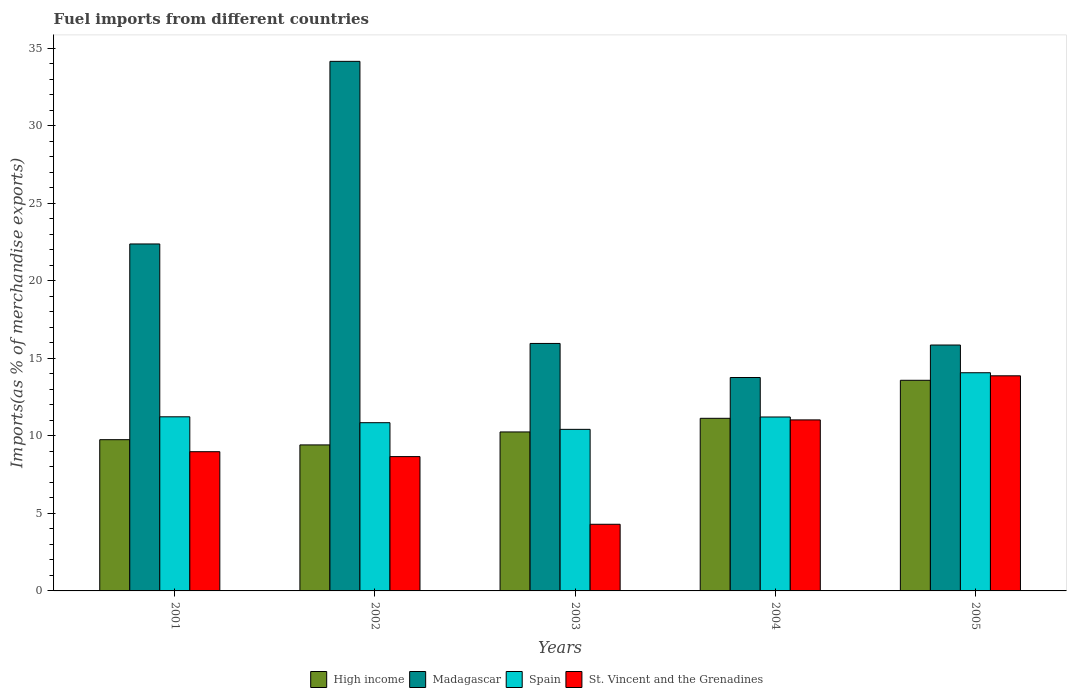How many different coloured bars are there?
Keep it short and to the point. 4. How many groups of bars are there?
Provide a short and direct response. 5. Are the number of bars per tick equal to the number of legend labels?
Your response must be concise. Yes. How many bars are there on the 2nd tick from the left?
Provide a short and direct response. 4. What is the percentage of imports to different countries in Spain in 2005?
Give a very brief answer. 14.07. Across all years, what is the maximum percentage of imports to different countries in High income?
Keep it short and to the point. 13.59. Across all years, what is the minimum percentage of imports to different countries in High income?
Ensure brevity in your answer.  9.42. In which year was the percentage of imports to different countries in St. Vincent and the Grenadines maximum?
Give a very brief answer. 2005. In which year was the percentage of imports to different countries in High income minimum?
Provide a succinct answer. 2002. What is the total percentage of imports to different countries in St. Vincent and the Grenadines in the graph?
Provide a succinct answer. 46.86. What is the difference between the percentage of imports to different countries in St. Vincent and the Grenadines in 2001 and that in 2004?
Make the answer very short. -2.05. What is the difference between the percentage of imports to different countries in Spain in 2001 and the percentage of imports to different countries in High income in 2002?
Provide a short and direct response. 1.81. What is the average percentage of imports to different countries in High income per year?
Your answer should be compact. 10.83. In the year 2003, what is the difference between the percentage of imports to different countries in Madagascar and percentage of imports to different countries in St. Vincent and the Grenadines?
Offer a terse response. 11.66. What is the ratio of the percentage of imports to different countries in High income in 2001 to that in 2002?
Make the answer very short. 1.04. Is the difference between the percentage of imports to different countries in Madagascar in 2004 and 2005 greater than the difference between the percentage of imports to different countries in St. Vincent and the Grenadines in 2004 and 2005?
Provide a short and direct response. Yes. What is the difference between the highest and the second highest percentage of imports to different countries in St. Vincent and the Grenadines?
Ensure brevity in your answer.  2.84. What is the difference between the highest and the lowest percentage of imports to different countries in Spain?
Make the answer very short. 3.65. In how many years, is the percentage of imports to different countries in Madagascar greater than the average percentage of imports to different countries in Madagascar taken over all years?
Provide a succinct answer. 2. Is the sum of the percentage of imports to different countries in High income in 2001 and 2003 greater than the maximum percentage of imports to different countries in Madagascar across all years?
Keep it short and to the point. No. Is it the case that in every year, the sum of the percentage of imports to different countries in Spain and percentage of imports to different countries in St. Vincent and the Grenadines is greater than the sum of percentage of imports to different countries in Madagascar and percentage of imports to different countries in High income?
Provide a succinct answer. No. What does the 2nd bar from the left in 2002 represents?
Make the answer very short. Madagascar. What does the 3rd bar from the right in 2002 represents?
Your answer should be very brief. Madagascar. Is it the case that in every year, the sum of the percentage of imports to different countries in High income and percentage of imports to different countries in Madagascar is greater than the percentage of imports to different countries in St. Vincent and the Grenadines?
Offer a terse response. Yes. How many bars are there?
Offer a terse response. 20. What is the difference between two consecutive major ticks on the Y-axis?
Your answer should be compact. 5. Does the graph contain grids?
Your answer should be very brief. No. Where does the legend appear in the graph?
Make the answer very short. Bottom center. How many legend labels are there?
Provide a succinct answer. 4. How are the legend labels stacked?
Keep it short and to the point. Horizontal. What is the title of the graph?
Your answer should be very brief. Fuel imports from different countries. Does "Botswana" appear as one of the legend labels in the graph?
Provide a succinct answer. No. What is the label or title of the Y-axis?
Ensure brevity in your answer.  Imports(as % of merchandise exports). What is the Imports(as % of merchandise exports) in High income in 2001?
Make the answer very short. 9.76. What is the Imports(as % of merchandise exports) of Madagascar in 2001?
Offer a terse response. 22.38. What is the Imports(as % of merchandise exports) of Spain in 2001?
Provide a succinct answer. 11.23. What is the Imports(as % of merchandise exports) in St. Vincent and the Grenadines in 2001?
Your answer should be compact. 8.98. What is the Imports(as % of merchandise exports) of High income in 2002?
Keep it short and to the point. 9.42. What is the Imports(as % of merchandise exports) in Madagascar in 2002?
Give a very brief answer. 34.16. What is the Imports(as % of merchandise exports) in Spain in 2002?
Give a very brief answer. 10.85. What is the Imports(as % of merchandise exports) in St. Vincent and the Grenadines in 2002?
Your answer should be compact. 8.67. What is the Imports(as % of merchandise exports) in High income in 2003?
Offer a terse response. 10.26. What is the Imports(as % of merchandise exports) in Madagascar in 2003?
Make the answer very short. 15.96. What is the Imports(as % of merchandise exports) in Spain in 2003?
Provide a short and direct response. 10.42. What is the Imports(as % of merchandise exports) in St. Vincent and the Grenadines in 2003?
Offer a terse response. 4.3. What is the Imports(as % of merchandise exports) in High income in 2004?
Keep it short and to the point. 11.14. What is the Imports(as % of merchandise exports) in Madagascar in 2004?
Offer a very short reply. 13.77. What is the Imports(as % of merchandise exports) in Spain in 2004?
Provide a succinct answer. 11.22. What is the Imports(as % of merchandise exports) of St. Vincent and the Grenadines in 2004?
Give a very brief answer. 11.03. What is the Imports(as % of merchandise exports) of High income in 2005?
Your answer should be compact. 13.59. What is the Imports(as % of merchandise exports) of Madagascar in 2005?
Keep it short and to the point. 15.86. What is the Imports(as % of merchandise exports) of Spain in 2005?
Give a very brief answer. 14.07. What is the Imports(as % of merchandise exports) of St. Vincent and the Grenadines in 2005?
Make the answer very short. 13.88. Across all years, what is the maximum Imports(as % of merchandise exports) of High income?
Keep it short and to the point. 13.59. Across all years, what is the maximum Imports(as % of merchandise exports) in Madagascar?
Offer a terse response. 34.16. Across all years, what is the maximum Imports(as % of merchandise exports) in Spain?
Your answer should be very brief. 14.07. Across all years, what is the maximum Imports(as % of merchandise exports) in St. Vincent and the Grenadines?
Offer a very short reply. 13.88. Across all years, what is the minimum Imports(as % of merchandise exports) in High income?
Make the answer very short. 9.42. Across all years, what is the minimum Imports(as % of merchandise exports) in Madagascar?
Your response must be concise. 13.77. Across all years, what is the minimum Imports(as % of merchandise exports) of Spain?
Ensure brevity in your answer.  10.42. Across all years, what is the minimum Imports(as % of merchandise exports) in St. Vincent and the Grenadines?
Ensure brevity in your answer.  4.3. What is the total Imports(as % of merchandise exports) of High income in the graph?
Provide a succinct answer. 54.15. What is the total Imports(as % of merchandise exports) in Madagascar in the graph?
Offer a very short reply. 102.14. What is the total Imports(as % of merchandise exports) of Spain in the graph?
Your answer should be very brief. 57.8. What is the total Imports(as % of merchandise exports) of St. Vincent and the Grenadines in the graph?
Make the answer very short. 46.86. What is the difference between the Imports(as % of merchandise exports) in High income in 2001 and that in 2002?
Offer a terse response. 0.34. What is the difference between the Imports(as % of merchandise exports) in Madagascar in 2001 and that in 2002?
Your response must be concise. -11.78. What is the difference between the Imports(as % of merchandise exports) in Spain in 2001 and that in 2002?
Offer a terse response. 0.38. What is the difference between the Imports(as % of merchandise exports) of St. Vincent and the Grenadines in 2001 and that in 2002?
Provide a succinct answer. 0.32. What is the difference between the Imports(as % of merchandise exports) in High income in 2001 and that in 2003?
Ensure brevity in your answer.  -0.5. What is the difference between the Imports(as % of merchandise exports) in Madagascar in 2001 and that in 2003?
Provide a short and direct response. 6.42. What is the difference between the Imports(as % of merchandise exports) in Spain in 2001 and that in 2003?
Your answer should be compact. 0.81. What is the difference between the Imports(as % of merchandise exports) of St. Vincent and the Grenadines in 2001 and that in 2003?
Provide a succinct answer. 4.68. What is the difference between the Imports(as % of merchandise exports) in High income in 2001 and that in 2004?
Provide a succinct answer. -1.38. What is the difference between the Imports(as % of merchandise exports) of Madagascar in 2001 and that in 2004?
Your answer should be very brief. 8.61. What is the difference between the Imports(as % of merchandise exports) in Spain in 2001 and that in 2004?
Your answer should be compact. 0.01. What is the difference between the Imports(as % of merchandise exports) of St. Vincent and the Grenadines in 2001 and that in 2004?
Make the answer very short. -2.05. What is the difference between the Imports(as % of merchandise exports) of High income in 2001 and that in 2005?
Make the answer very short. -3.83. What is the difference between the Imports(as % of merchandise exports) of Madagascar in 2001 and that in 2005?
Give a very brief answer. 6.52. What is the difference between the Imports(as % of merchandise exports) in Spain in 2001 and that in 2005?
Keep it short and to the point. -2.84. What is the difference between the Imports(as % of merchandise exports) of St. Vincent and the Grenadines in 2001 and that in 2005?
Your answer should be compact. -4.9. What is the difference between the Imports(as % of merchandise exports) in High income in 2002 and that in 2003?
Provide a succinct answer. -0.84. What is the difference between the Imports(as % of merchandise exports) of Madagascar in 2002 and that in 2003?
Make the answer very short. 18.2. What is the difference between the Imports(as % of merchandise exports) of Spain in 2002 and that in 2003?
Make the answer very short. 0.43. What is the difference between the Imports(as % of merchandise exports) of St. Vincent and the Grenadines in 2002 and that in 2003?
Provide a short and direct response. 4.37. What is the difference between the Imports(as % of merchandise exports) in High income in 2002 and that in 2004?
Your answer should be very brief. -1.72. What is the difference between the Imports(as % of merchandise exports) of Madagascar in 2002 and that in 2004?
Keep it short and to the point. 20.39. What is the difference between the Imports(as % of merchandise exports) in Spain in 2002 and that in 2004?
Your response must be concise. -0.37. What is the difference between the Imports(as % of merchandise exports) of St. Vincent and the Grenadines in 2002 and that in 2004?
Your answer should be very brief. -2.37. What is the difference between the Imports(as % of merchandise exports) in High income in 2002 and that in 2005?
Your answer should be compact. -4.17. What is the difference between the Imports(as % of merchandise exports) of Madagascar in 2002 and that in 2005?
Your answer should be very brief. 18.3. What is the difference between the Imports(as % of merchandise exports) in Spain in 2002 and that in 2005?
Make the answer very short. -3.22. What is the difference between the Imports(as % of merchandise exports) of St. Vincent and the Grenadines in 2002 and that in 2005?
Your response must be concise. -5.21. What is the difference between the Imports(as % of merchandise exports) of High income in 2003 and that in 2004?
Your answer should be very brief. -0.88. What is the difference between the Imports(as % of merchandise exports) of Madagascar in 2003 and that in 2004?
Make the answer very short. 2.2. What is the difference between the Imports(as % of merchandise exports) in Spain in 2003 and that in 2004?
Provide a succinct answer. -0.8. What is the difference between the Imports(as % of merchandise exports) of St. Vincent and the Grenadines in 2003 and that in 2004?
Ensure brevity in your answer.  -6.73. What is the difference between the Imports(as % of merchandise exports) in High income in 2003 and that in 2005?
Ensure brevity in your answer.  -3.33. What is the difference between the Imports(as % of merchandise exports) in Madagascar in 2003 and that in 2005?
Give a very brief answer. 0.1. What is the difference between the Imports(as % of merchandise exports) in Spain in 2003 and that in 2005?
Provide a short and direct response. -3.65. What is the difference between the Imports(as % of merchandise exports) in St. Vincent and the Grenadines in 2003 and that in 2005?
Keep it short and to the point. -9.58. What is the difference between the Imports(as % of merchandise exports) in High income in 2004 and that in 2005?
Make the answer very short. -2.45. What is the difference between the Imports(as % of merchandise exports) in Madagascar in 2004 and that in 2005?
Your answer should be very brief. -2.09. What is the difference between the Imports(as % of merchandise exports) in Spain in 2004 and that in 2005?
Keep it short and to the point. -2.85. What is the difference between the Imports(as % of merchandise exports) of St. Vincent and the Grenadines in 2004 and that in 2005?
Ensure brevity in your answer.  -2.84. What is the difference between the Imports(as % of merchandise exports) of High income in 2001 and the Imports(as % of merchandise exports) of Madagascar in 2002?
Give a very brief answer. -24.41. What is the difference between the Imports(as % of merchandise exports) in High income in 2001 and the Imports(as % of merchandise exports) in Spain in 2002?
Provide a short and direct response. -1.1. What is the difference between the Imports(as % of merchandise exports) in High income in 2001 and the Imports(as % of merchandise exports) in St. Vincent and the Grenadines in 2002?
Make the answer very short. 1.09. What is the difference between the Imports(as % of merchandise exports) in Madagascar in 2001 and the Imports(as % of merchandise exports) in Spain in 2002?
Offer a very short reply. 11.53. What is the difference between the Imports(as % of merchandise exports) in Madagascar in 2001 and the Imports(as % of merchandise exports) in St. Vincent and the Grenadines in 2002?
Offer a very short reply. 13.72. What is the difference between the Imports(as % of merchandise exports) in Spain in 2001 and the Imports(as % of merchandise exports) in St. Vincent and the Grenadines in 2002?
Keep it short and to the point. 2.57. What is the difference between the Imports(as % of merchandise exports) in High income in 2001 and the Imports(as % of merchandise exports) in Madagascar in 2003?
Give a very brief answer. -6.21. What is the difference between the Imports(as % of merchandise exports) in High income in 2001 and the Imports(as % of merchandise exports) in Spain in 2003?
Provide a succinct answer. -0.67. What is the difference between the Imports(as % of merchandise exports) in High income in 2001 and the Imports(as % of merchandise exports) in St. Vincent and the Grenadines in 2003?
Offer a terse response. 5.46. What is the difference between the Imports(as % of merchandise exports) of Madagascar in 2001 and the Imports(as % of merchandise exports) of Spain in 2003?
Provide a succinct answer. 11.96. What is the difference between the Imports(as % of merchandise exports) in Madagascar in 2001 and the Imports(as % of merchandise exports) in St. Vincent and the Grenadines in 2003?
Keep it short and to the point. 18.08. What is the difference between the Imports(as % of merchandise exports) in Spain in 2001 and the Imports(as % of merchandise exports) in St. Vincent and the Grenadines in 2003?
Give a very brief answer. 6.93. What is the difference between the Imports(as % of merchandise exports) of High income in 2001 and the Imports(as % of merchandise exports) of Madagascar in 2004?
Make the answer very short. -4.01. What is the difference between the Imports(as % of merchandise exports) of High income in 2001 and the Imports(as % of merchandise exports) of Spain in 2004?
Your answer should be compact. -1.46. What is the difference between the Imports(as % of merchandise exports) of High income in 2001 and the Imports(as % of merchandise exports) of St. Vincent and the Grenadines in 2004?
Your answer should be very brief. -1.28. What is the difference between the Imports(as % of merchandise exports) in Madagascar in 2001 and the Imports(as % of merchandise exports) in Spain in 2004?
Your answer should be compact. 11.16. What is the difference between the Imports(as % of merchandise exports) of Madagascar in 2001 and the Imports(as % of merchandise exports) of St. Vincent and the Grenadines in 2004?
Keep it short and to the point. 11.35. What is the difference between the Imports(as % of merchandise exports) of Spain in 2001 and the Imports(as % of merchandise exports) of St. Vincent and the Grenadines in 2004?
Your response must be concise. 0.2. What is the difference between the Imports(as % of merchandise exports) of High income in 2001 and the Imports(as % of merchandise exports) of Madagascar in 2005?
Ensure brevity in your answer.  -6.11. What is the difference between the Imports(as % of merchandise exports) in High income in 2001 and the Imports(as % of merchandise exports) in Spain in 2005?
Keep it short and to the point. -4.32. What is the difference between the Imports(as % of merchandise exports) of High income in 2001 and the Imports(as % of merchandise exports) of St. Vincent and the Grenadines in 2005?
Provide a short and direct response. -4.12. What is the difference between the Imports(as % of merchandise exports) of Madagascar in 2001 and the Imports(as % of merchandise exports) of Spain in 2005?
Your answer should be compact. 8.31. What is the difference between the Imports(as % of merchandise exports) of Madagascar in 2001 and the Imports(as % of merchandise exports) of St. Vincent and the Grenadines in 2005?
Keep it short and to the point. 8.51. What is the difference between the Imports(as % of merchandise exports) in Spain in 2001 and the Imports(as % of merchandise exports) in St. Vincent and the Grenadines in 2005?
Your answer should be very brief. -2.64. What is the difference between the Imports(as % of merchandise exports) in High income in 2002 and the Imports(as % of merchandise exports) in Madagascar in 2003?
Give a very brief answer. -6.55. What is the difference between the Imports(as % of merchandise exports) of High income in 2002 and the Imports(as % of merchandise exports) of Spain in 2003?
Give a very brief answer. -1. What is the difference between the Imports(as % of merchandise exports) of High income in 2002 and the Imports(as % of merchandise exports) of St. Vincent and the Grenadines in 2003?
Your answer should be very brief. 5.12. What is the difference between the Imports(as % of merchandise exports) in Madagascar in 2002 and the Imports(as % of merchandise exports) in Spain in 2003?
Provide a short and direct response. 23.74. What is the difference between the Imports(as % of merchandise exports) in Madagascar in 2002 and the Imports(as % of merchandise exports) in St. Vincent and the Grenadines in 2003?
Your answer should be compact. 29.86. What is the difference between the Imports(as % of merchandise exports) of Spain in 2002 and the Imports(as % of merchandise exports) of St. Vincent and the Grenadines in 2003?
Provide a succinct answer. 6.55. What is the difference between the Imports(as % of merchandise exports) of High income in 2002 and the Imports(as % of merchandise exports) of Madagascar in 2004?
Offer a terse response. -4.35. What is the difference between the Imports(as % of merchandise exports) in High income in 2002 and the Imports(as % of merchandise exports) in Spain in 2004?
Give a very brief answer. -1.8. What is the difference between the Imports(as % of merchandise exports) of High income in 2002 and the Imports(as % of merchandise exports) of St. Vincent and the Grenadines in 2004?
Make the answer very short. -1.61. What is the difference between the Imports(as % of merchandise exports) of Madagascar in 2002 and the Imports(as % of merchandise exports) of Spain in 2004?
Offer a terse response. 22.94. What is the difference between the Imports(as % of merchandise exports) of Madagascar in 2002 and the Imports(as % of merchandise exports) of St. Vincent and the Grenadines in 2004?
Ensure brevity in your answer.  23.13. What is the difference between the Imports(as % of merchandise exports) in Spain in 2002 and the Imports(as % of merchandise exports) in St. Vincent and the Grenadines in 2004?
Provide a succinct answer. -0.18. What is the difference between the Imports(as % of merchandise exports) in High income in 2002 and the Imports(as % of merchandise exports) in Madagascar in 2005?
Your answer should be very brief. -6.44. What is the difference between the Imports(as % of merchandise exports) in High income in 2002 and the Imports(as % of merchandise exports) in Spain in 2005?
Ensure brevity in your answer.  -4.66. What is the difference between the Imports(as % of merchandise exports) of High income in 2002 and the Imports(as % of merchandise exports) of St. Vincent and the Grenadines in 2005?
Your answer should be very brief. -4.46. What is the difference between the Imports(as % of merchandise exports) in Madagascar in 2002 and the Imports(as % of merchandise exports) in Spain in 2005?
Provide a short and direct response. 20.09. What is the difference between the Imports(as % of merchandise exports) in Madagascar in 2002 and the Imports(as % of merchandise exports) in St. Vincent and the Grenadines in 2005?
Your response must be concise. 20.29. What is the difference between the Imports(as % of merchandise exports) of Spain in 2002 and the Imports(as % of merchandise exports) of St. Vincent and the Grenadines in 2005?
Offer a very short reply. -3.02. What is the difference between the Imports(as % of merchandise exports) of High income in 2003 and the Imports(as % of merchandise exports) of Madagascar in 2004?
Offer a very short reply. -3.51. What is the difference between the Imports(as % of merchandise exports) in High income in 2003 and the Imports(as % of merchandise exports) in Spain in 2004?
Your answer should be very brief. -0.96. What is the difference between the Imports(as % of merchandise exports) of High income in 2003 and the Imports(as % of merchandise exports) of St. Vincent and the Grenadines in 2004?
Your answer should be very brief. -0.78. What is the difference between the Imports(as % of merchandise exports) of Madagascar in 2003 and the Imports(as % of merchandise exports) of Spain in 2004?
Provide a succinct answer. 4.74. What is the difference between the Imports(as % of merchandise exports) in Madagascar in 2003 and the Imports(as % of merchandise exports) in St. Vincent and the Grenadines in 2004?
Provide a short and direct response. 4.93. What is the difference between the Imports(as % of merchandise exports) of Spain in 2003 and the Imports(as % of merchandise exports) of St. Vincent and the Grenadines in 2004?
Ensure brevity in your answer.  -0.61. What is the difference between the Imports(as % of merchandise exports) of High income in 2003 and the Imports(as % of merchandise exports) of Madagascar in 2005?
Your answer should be compact. -5.61. What is the difference between the Imports(as % of merchandise exports) in High income in 2003 and the Imports(as % of merchandise exports) in Spain in 2005?
Offer a terse response. -3.82. What is the difference between the Imports(as % of merchandise exports) of High income in 2003 and the Imports(as % of merchandise exports) of St. Vincent and the Grenadines in 2005?
Provide a succinct answer. -3.62. What is the difference between the Imports(as % of merchandise exports) in Madagascar in 2003 and the Imports(as % of merchandise exports) in Spain in 2005?
Make the answer very short. 1.89. What is the difference between the Imports(as % of merchandise exports) in Madagascar in 2003 and the Imports(as % of merchandise exports) in St. Vincent and the Grenadines in 2005?
Give a very brief answer. 2.09. What is the difference between the Imports(as % of merchandise exports) of Spain in 2003 and the Imports(as % of merchandise exports) of St. Vincent and the Grenadines in 2005?
Offer a terse response. -3.45. What is the difference between the Imports(as % of merchandise exports) in High income in 2004 and the Imports(as % of merchandise exports) in Madagascar in 2005?
Keep it short and to the point. -4.73. What is the difference between the Imports(as % of merchandise exports) in High income in 2004 and the Imports(as % of merchandise exports) in Spain in 2005?
Your answer should be compact. -2.94. What is the difference between the Imports(as % of merchandise exports) in High income in 2004 and the Imports(as % of merchandise exports) in St. Vincent and the Grenadines in 2005?
Offer a very short reply. -2.74. What is the difference between the Imports(as % of merchandise exports) in Madagascar in 2004 and the Imports(as % of merchandise exports) in Spain in 2005?
Give a very brief answer. -0.31. What is the difference between the Imports(as % of merchandise exports) in Madagascar in 2004 and the Imports(as % of merchandise exports) in St. Vincent and the Grenadines in 2005?
Offer a terse response. -0.11. What is the difference between the Imports(as % of merchandise exports) in Spain in 2004 and the Imports(as % of merchandise exports) in St. Vincent and the Grenadines in 2005?
Your response must be concise. -2.66. What is the average Imports(as % of merchandise exports) of High income per year?
Offer a terse response. 10.83. What is the average Imports(as % of merchandise exports) in Madagascar per year?
Keep it short and to the point. 20.43. What is the average Imports(as % of merchandise exports) in Spain per year?
Offer a very short reply. 11.56. What is the average Imports(as % of merchandise exports) in St. Vincent and the Grenadines per year?
Provide a succinct answer. 9.37. In the year 2001, what is the difference between the Imports(as % of merchandise exports) in High income and Imports(as % of merchandise exports) in Madagascar?
Ensure brevity in your answer.  -12.63. In the year 2001, what is the difference between the Imports(as % of merchandise exports) in High income and Imports(as % of merchandise exports) in Spain?
Provide a succinct answer. -1.48. In the year 2001, what is the difference between the Imports(as % of merchandise exports) in High income and Imports(as % of merchandise exports) in St. Vincent and the Grenadines?
Provide a short and direct response. 0.77. In the year 2001, what is the difference between the Imports(as % of merchandise exports) in Madagascar and Imports(as % of merchandise exports) in Spain?
Provide a short and direct response. 11.15. In the year 2001, what is the difference between the Imports(as % of merchandise exports) of Madagascar and Imports(as % of merchandise exports) of St. Vincent and the Grenadines?
Your response must be concise. 13.4. In the year 2001, what is the difference between the Imports(as % of merchandise exports) in Spain and Imports(as % of merchandise exports) in St. Vincent and the Grenadines?
Keep it short and to the point. 2.25. In the year 2002, what is the difference between the Imports(as % of merchandise exports) of High income and Imports(as % of merchandise exports) of Madagascar?
Provide a succinct answer. -24.74. In the year 2002, what is the difference between the Imports(as % of merchandise exports) of High income and Imports(as % of merchandise exports) of Spain?
Keep it short and to the point. -1.43. In the year 2002, what is the difference between the Imports(as % of merchandise exports) of High income and Imports(as % of merchandise exports) of St. Vincent and the Grenadines?
Provide a succinct answer. 0.75. In the year 2002, what is the difference between the Imports(as % of merchandise exports) of Madagascar and Imports(as % of merchandise exports) of Spain?
Your response must be concise. 23.31. In the year 2002, what is the difference between the Imports(as % of merchandise exports) of Madagascar and Imports(as % of merchandise exports) of St. Vincent and the Grenadines?
Your answer should be very brief. 25.5. In the year 2002, what is the difference between the Imports(as % of merchandise exports) of Spain and Imports(as % of merchandise exports) of St. Vincent and the Grenadines?
Keep it short and to the point. 2.19. In the year 2003, what is the difference between the Imports(as % of merchandise exports) in High income and Imports(as % of merchandise exports) in Madagascar?
Make the answer very short. -5.71. In the year 2003, what is the difference between the Imports(as % of merchandise exports) of High income and Imports(as % of merchandise exports) of Spain?
Your answer should be very brief. -0.17. In the year 2003, what is the difference between the Imports(as % of merchandise exports) in High income and Imports(as % of merchandise exports) in St. Vincent and the Grenadines?
Offer a terse response. 5.96. In the year 2003, what is the difference between the Imports(as % of merchandise exports) in Madagascar and Imports(as % of merchandise exports) in Spain?
Provide a short and direct response. 5.54. In the year 2003, what is the difference between the Imports(as % of merchandise exports) of Madagascar and Imports(as % of merchandise exports) of St. Vincent and the Grenadines?
Provide a short and direct response. 11.66. In the year 2003, what is the difference between the Imports(as % of merchandise exports) in Spain and Imports(as % of merchandise exports) in St. Vincent and the Grenadines?
Provide a succinct answer. 6.12. In the year 2004, what is the difference between the Imports(as % of merchandise exports) of High income and Imports(as % of merchandise exports) of Madagascar?
Ensure brevity in your answer.  -2.63. In the year 2004, what is the difference between the Imports(as % of merchandise exports) in High income and Imports(as % of merchandise exports) in Spain?
Provide a succinct answer. -0.08. In the year 2004, what is the difference between the Imports(as % of merchandise exports) of High income and Imports(as % of merchandise exports) of St. Vincent and the Grenadines?
Give a very brief answer. 0.1. In the year 2004, what is the difference between the Imports(as % of merchandise exports) of Madagascar and Imports(as % of merchandise exports) of Spain?
Your response must be concise. 2.55. In the year 2004, what is the difference between the Imports(as % of merchandise exports) in Madagascar and Imports(as % of merchandise exports) in St. Vincent and the Grenadines?
Offer a very short reply. 2.74. In the year 2004, what is the difference between the Imports(as % of merchandise exports) in Spain and Imports(as % of merchandise exports) in St. Vincent and the Grenadines?
Offer a terse response. 0.19. In the year 2005, what is the difference between the Imports(as % of merchandise exports) in High income and Imports(as % of merchandise exports) in Madagascar?
Your answer should be compact. -2.28. In the year 2005, what is the difference between the Imports(as % of merchandise exports) of High income and Imports(as % of merchandise exports) of Spain?
Your answer should be very brief. -0.49. In the year 2005, what is the difference between the Imports(as % of merchandise exports) of High income and Imports(as % of merchandise exports) of St. Vincent and the Grenadines?
Offer a very short reply. -0.29. In the year 2005, what is the difference between the Imports(as % of merchandise exports) in Madagascar and Imports(as % of merchandise exports) in Spain?
Provide a succinct answer. 1.79. In the year 2005, what is the difference between the Imports(as % of merchandise exports) in Madagascar and Imports(as % of merchandise exports) in St. Vincent and the Grenadines?
Provide a succinct answer. 1.99. In the year 2005, what is the difference between the Imports(as % of merchandise exports) of Spain and Imports(as % of merchandise exports) of St. Vincent and the Grenadines?
Offer a very short reply. 0.2. What is the ratio of the Imports(as % of merchandise exports) of High income in 2001 to that in 2002?
Offer a terse response. 1.04. What is the ratio of the Imports(as % of merchandise exports) in Madagascar in 2001 to that in 2002?
Offer a very short reply. 0.66. What is the ratio of the Imports(as % of merchandise exports) of Spain in 2001 to that in 2002?
Offer a very short reply. 1.04. What is the ratio of the Imports(as % of merchandise exports) of St. Vincent and the Grenadines in 2001 to that in 2002?
Provide a succinct answer. 1.04. What is the ratio of the Imports(as % of merchandise exports) of High income in 2001 to that in 2003?
Ensure brevity in your answer.  0.95. What is the ratio of the Imports(as % of merchandise exports) in Madagascar in 2001 to that in 2003?
Make the answer very short. 1.4. What is the ratio of the Imports(as % of merchandise exports) of Spain in 2001 to that in 2003?
Your response must be concise. 1.08. What is the ratio of the Imports(as % of merchandise exports) in St. Vincent and the Grenadines in 2001 to that in 2003?
Provide a short and direct response. 2.09. What is the ratio of the Imports(as % of merchandise exports) of High income in 2001 to that in 2004?
Offer a very short reply. 0.88. What is the ratio of the Imports(as % of merchandise exports) in Madagascar in 2001 to that in 2004?
Your response must be concise. 1.63. What is the ratio of the Imports(as % of merchandise exports) of St. Vincent and the Grenadines in 2001 to that in 2004?
Offer a very short reply. 0.81. What is the ratio of the Imports(as % of merchandise exports) in High income in 2001 to that in 2005?
Keep it short and to the point. 0.72. What is the ratio of the Imports(as % of merchandise exports) in Madagascar in 2001 to that in 2005?
Your answer should be very brief. 1.41. What is the ratio of the Imports(as % of merchandise exports) of Spain in 2001 to that in 2005?
Make the answer very short. 0.8. What is the ratio of the Imports(as % of merchandise exports) in St. Vincent and the Grenadines in 2001 to that in 2005?
Make the answer very short. 0.65. What is the ratio of the Imports(as % of merchandise exports) in High income in 2002 to that in 2003?
Keep it short and to the point. 0.92. What is the ratio of the Imports(as % of merchandise exports) of Madagascar in 2002 to that in 2003?
Provide a short and direct response. 2.14. What is the ratio of the Imports(as % of merchandise exports) of Spain in 2002 to that in 2003?
Give a very brief answer. 1.04. What is the ratio of the Imports(as % of merchandise exports) in St. Vincent and the Grenadines in 2002 to that in 2003?
Provide a succinct answer. 2.02. What is the ratio of the Imports(as % of merchandise exports) in High income in 2002 to that in 2004?
Make the answer very short. 0.85. What is the ratio of the Imports(as % of merchandise exports) of Madagascar in 2002 to that in 2004?
Offer a very short reply. 2.48. What is the ratio of the Imports(as % of merchandise exports) in Spain in 2002 to that in 2004?
Offer a terse response. 0.97. What is the ratio of the Imports(as % of merchandise exports) of St. Vincent and the Grenadines in 2002 to that in 2004?
Make the answer very short. 0.79. What is the ratio of the Imports(as % of merchandise exports) in High income in 2002 to that in 2005?
Your answer should be compact. 0.69. What is the ratio of the Imports(as % of merchandise exports) in Madagascar in 2002 to that in 2005?
Your answer should be very brief. 2.15. What is the ratio of the Imports(as % of merchandise exports) of Spain in 2002 to that in 2005?
Ensure brevity in your answer.  0.77. What is the ratio of the Imports(as % of merchandise exports) of St. Vincent and the Grenadines in 2002 to that in 2005?
Offer a very short reply. 0.62. What is the ratio of the Imports(as % of merchandise exports) of High income in 2003 to that in 2004?
Provide a succinct answer. 0.92. What is the ratio of the Imports(as % of merchandise exports) in Madagascar in 2003 to that in 2004?
Keep it short and to the point. 1.16. What is the ratio of the Imports(as % of merchandise exports) in Spain in 2003 to that in 2004?
Your response must be concise. 0.93. What is the ratio of the Imports(as % of merchandise exports) in St. Vincent and the Grenadines in 2003 to that in 2004?
Your answer should be compact. 0.39. What is the ratio of the Imports(as % of merchandise exports) of High income in 2003 to that in 2005?
Provide a short and direct response. 0.75. What is the ratio of the Imports(as % of merchandise exports) of Madagascar in 2003 to that in 2005?
Offer a terse response. 1.01. What is the ratio of the Imports(as % of merchandise exports) in Spain in 2003 to that in 2005?
Your answer should be very brief. 0.74. What is the ratio of the Imports(as % of merchandise exports) of St. Vincent and the Grenadines in 2003 to that in 2005?
Offer a terse response. 0.31. What is the ratio of the Imports(as % of merchandise exports) of High income in 2004 to that in 2005?
Provide a succinct answer. 0.82. What is the ratio of the Imports(as % of merchandise exports) of Madagascar in 2004 to that in 2005?
Provide a short and direct response. 0.87. What is the ratio of the Imports(as % of merchandise exports) in Spain in 2004 to that in 2005?
Your answer should be very brief. 0.8. What is the ratio of the Imports(as % of merchandise exports) in St. Vincent and the Grenadines in 2004 to that in 2005?
Offer a very short reply. 0.8. What is the difference between the highest and the second highest Imports(as % of merchandise exports) in High income?
Keep it short and to the point. 2.45. What is the difference between the highest and the second highest Imports(as % of merchandise exports) of Madagascar?
Ensure brevity in your answer.  11.78. What is the difference between the highest and the second highest Imports(as % of merchandise exports) of Spain?
Your answer should be very brief. 2.84. What is the difference between the highest and the second highest Imports(as % of merchandise exports) of St. Vincent and the Grenadines?
Give a very brief answer. 2.84. What is the difference between the highest and the lowest Imports(as % of merchandise exports) in High income?
Provide a short and direct response. 4.17. What is the difference between the highest and the lowest Imports(as % of merchandise exports) in Madagascar?
Provide a short and direct response. 20.39. What is the difference between the highest and the lowest Imports(as % of merchandise exports) of Spain?
Keep it short and to the point. 3.65. What is the difference between the highest and the lowest Imports(as % of merchandise exports) of St. Vincent and the Grenadines?
Make the answer very short. 9.58. 